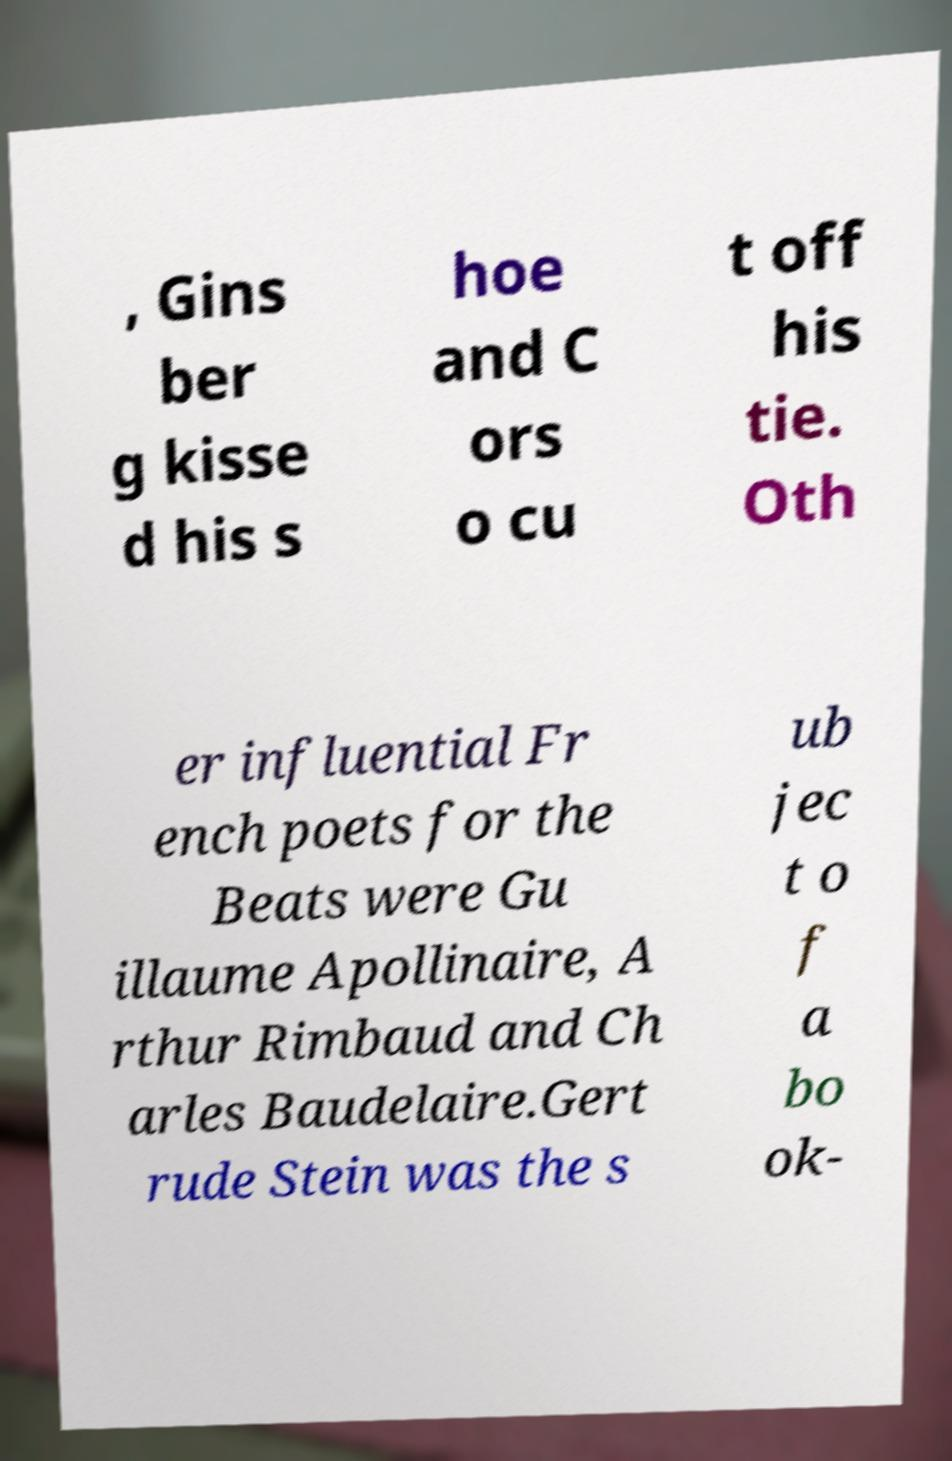Can you accurately transcribe the text from the provided image for me? , Gins ber g kisse d his s hoe and C ors o cu t off his tie. Oth er influential Fr ench poets for the Beats were Gu illaume Apollinaire, A rthur Rimbaud and Ch arles Baudelaire.Gert rude Stein was the s ub jec t o f a bo ok- 